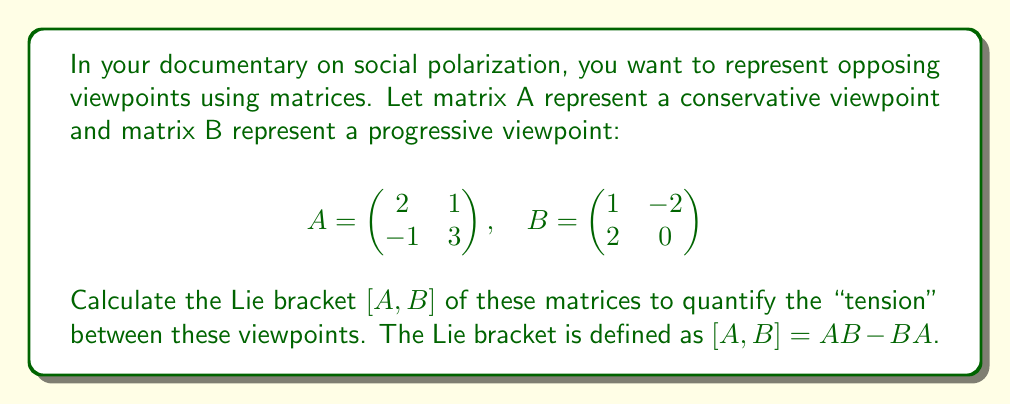Give your solution to this math problem. To solve this problem, we need to follow these steps:

1) First, calculate AB:
   $$AB = \begin{pmatrix} 2 & 1 \\ -1 & 3 \end{pmatrix} \begin{pmatrix} 1 & -2 \\ 2 & 0 \end{pmatrix}$$
   $$AB = \begin{pmatrix} (2\cdot1 + 1\cdot2) & (2\cdot(-2) + 1\cdot0) \\ (-1\cdot1 + 3\cdot2) & (-1\cdot(-2) + 3\cdot0) \end{pmatrix}$$
   $$AB = \begin{pmatrix} 4 & -4 \\ 5 & 2 \end{pmatrix}$$

2) Next, calculate BA:
   $$BA = \begin{pmatrix} 1 & -2 \\ 2 & 0 \end{pmatrix} \begin{pmatrix} 2 & 1 \\ -1 & 3 \end{pmatrix}$$
   $$BA = \begin{pmatrix} (1\cdot2 + (-2)\cdot(-1)) & (1\cdot1 + (-2)\cdot3) \\ (2\cdot2 + 0\cdot(-1)) & (2\cdot1 + 0\cdot3) \end{pmatrix}$$
   $$BA = \begin{pmatrix} 4 & -5 \\ 4 & 2 \end{pmatrix}$$

3) Now, we can calculate the Lie bracket $[A,B] = AB - BA$:
   $$[A,B] = \begin{pmatrix} 4 & -4 \\ 5 & 2 \end{pmatrix} - \begin{pmatrix} 4 & -5 \\ 4 & 2 \end{pmatrix}$$
   $$[A,B] = \begin{pmatrix} 4-4 & (-4)-(-5) \\ 5-4 & 2-2 \end{pmatrix}$$
   $$[A,B] = \begin{pmatrix} 0 & 1 \\ 1 & 0 \end{pmatrix}$$

This result quantifies the "tension" or difference between the two viewpoints represented by matrices A and B.
Answer: The Lie bracket $[A,B]$ is $$\begin{pmatrix} 0 & 1 \\ 1 & 0 \end{pmatrix}$$ 